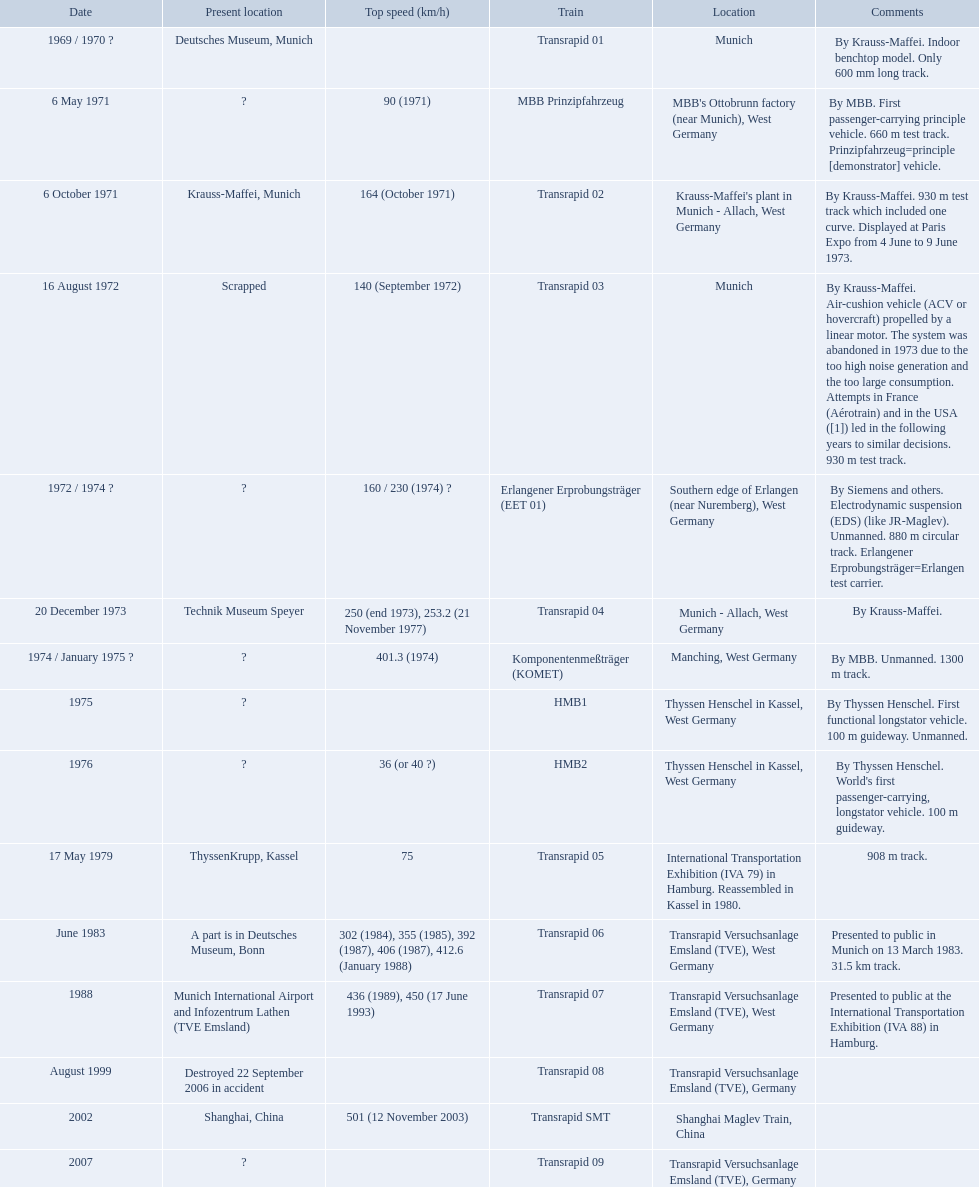Which trains exceeded a top speed of 400+? Komponentenmeßträger (KOMET), Transrapid 07, Transrapid SMT. How about 500+? Transrapid SMT. 